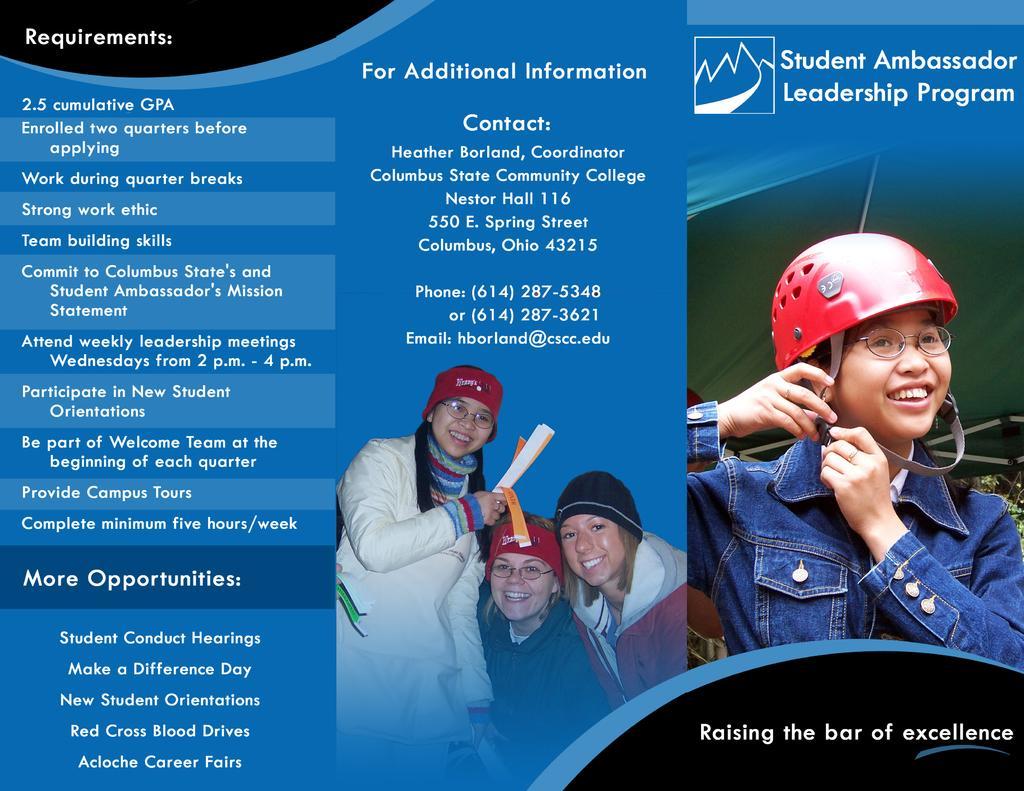Describe this image in one or two sentences. This is a poster. In this poster something is written. In the center there are three girls. They are wearing caps. And two are wearing specs. One is holding papers. On the right side a girl is wearing a specs and helmet. 